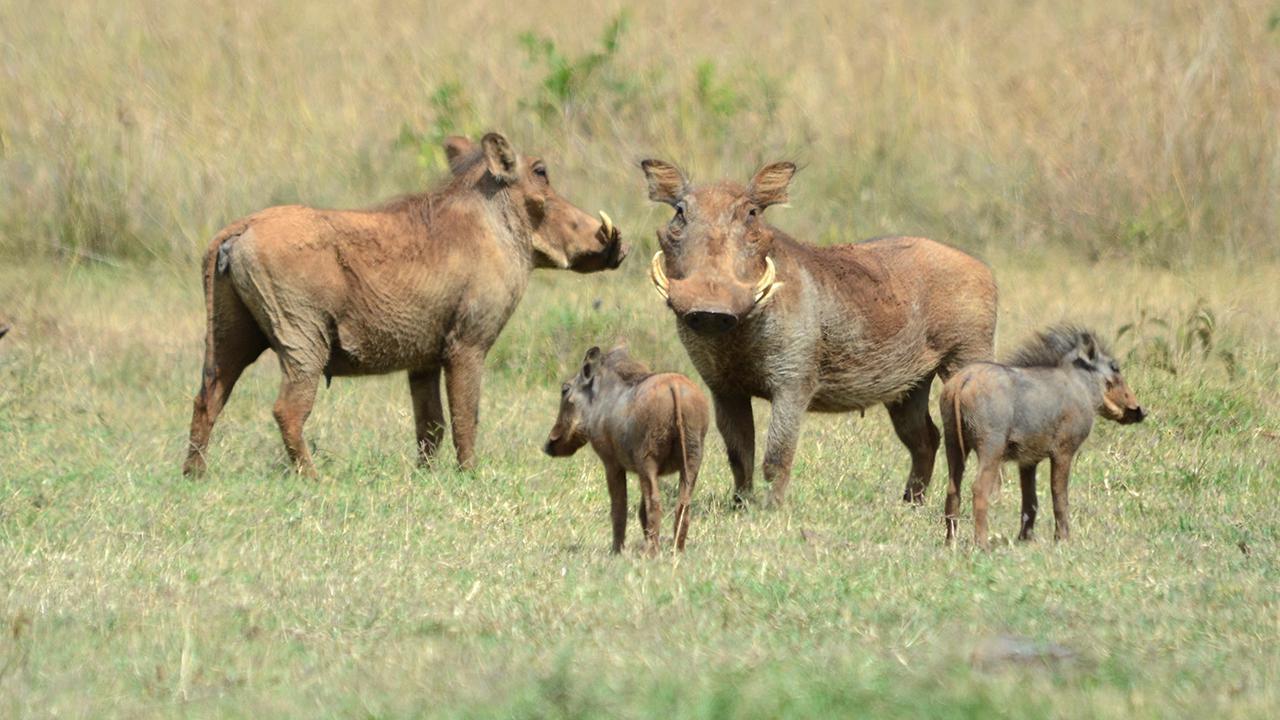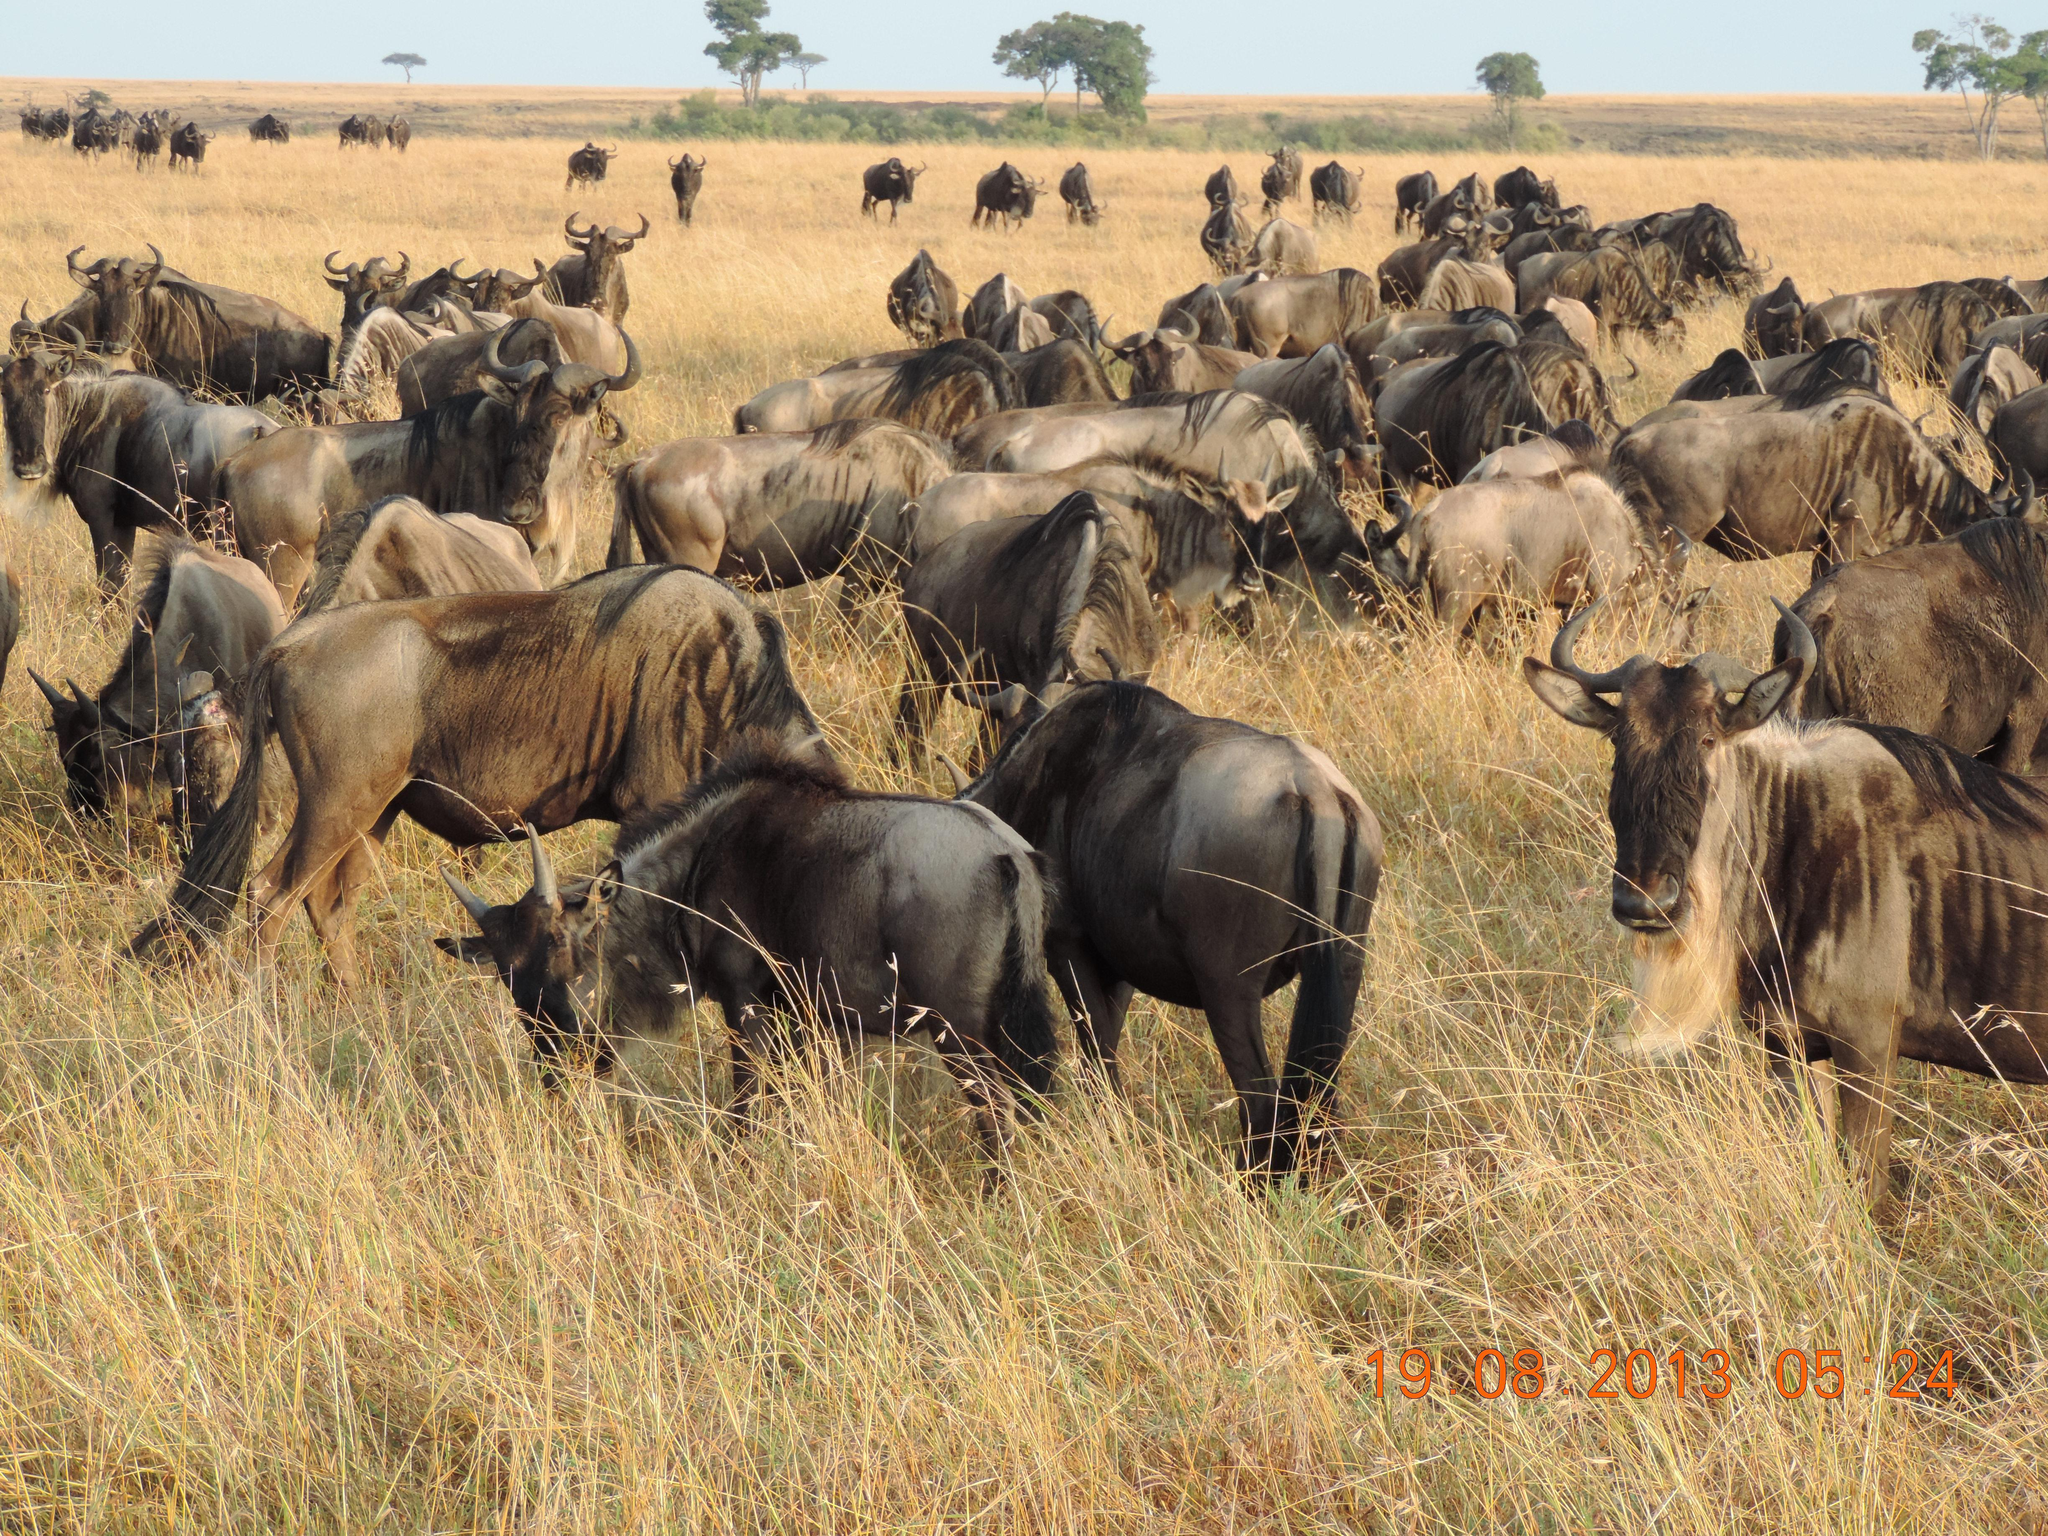The first image is the image on the left, the second image is the image on the right. Assess this claim about the two images: "One of the images shows at least one adult boar with four or less babies.". Correct or not? Answer yes or no. Yes. 